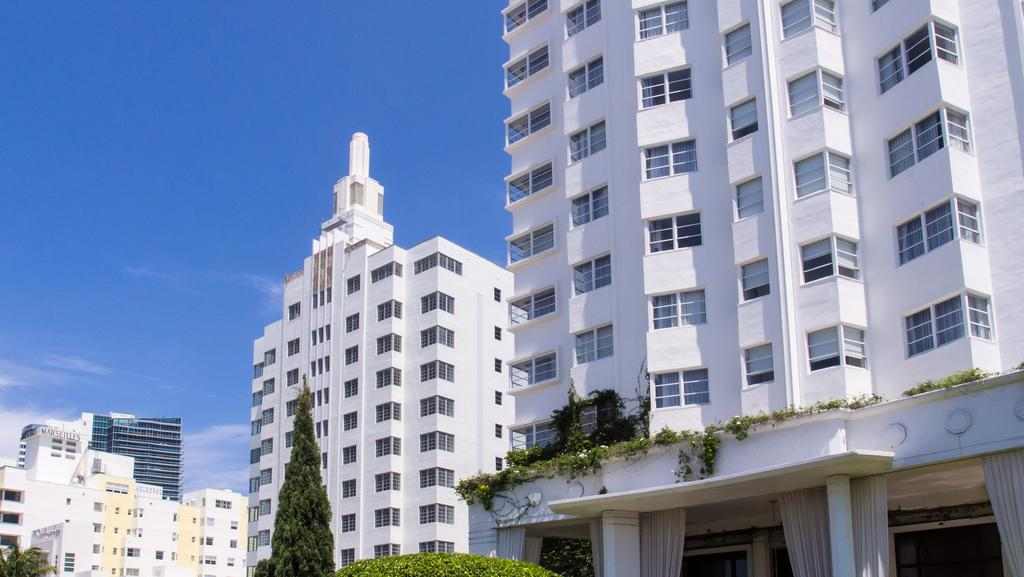What type of structures can be seen in the image? There are many buildings in the image. What else is visible in front of the buildings? Trees are visible in front of the buildings. What can be seen in the background of the image? The sky is visible in the background of the image. What color is the crayon used to draw the buildings in the image? There is no crayon present in the image; it is a photograph or illustration of actual buildings. 